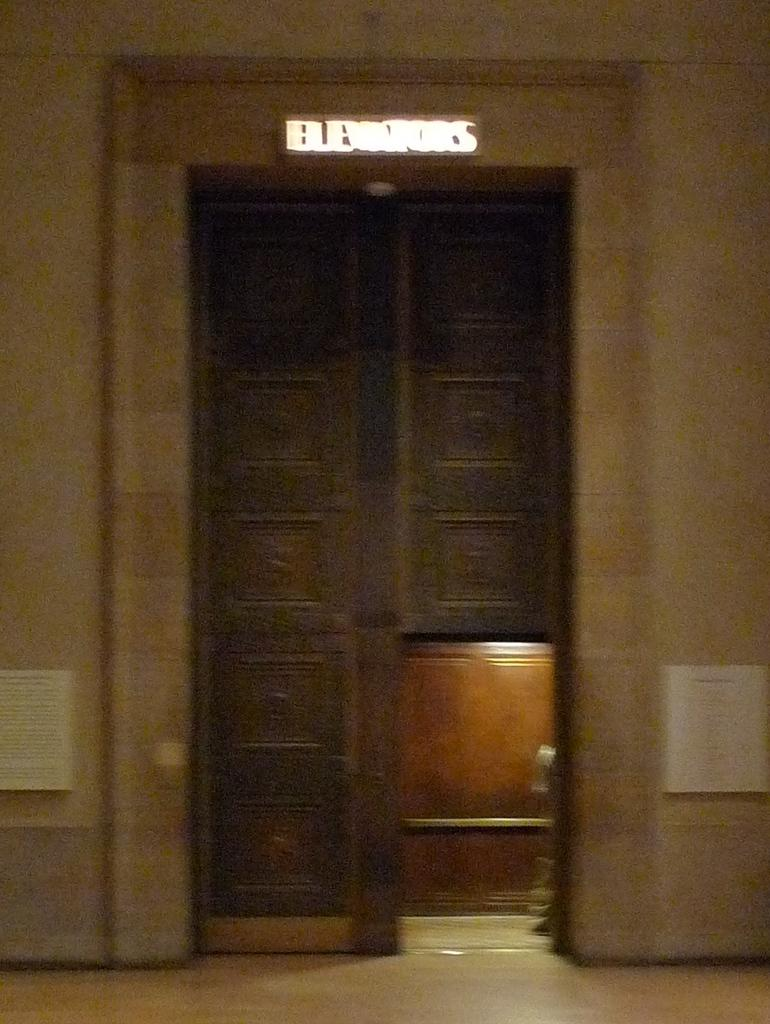What is the main subject of the image? The main subject of the image is a door. Can you describe the location of the door in the image? The door is in the center of the image. What type of magic is being performed near the door in the image? There is no indication of magic or any magical activity in the image; it only features a door. 